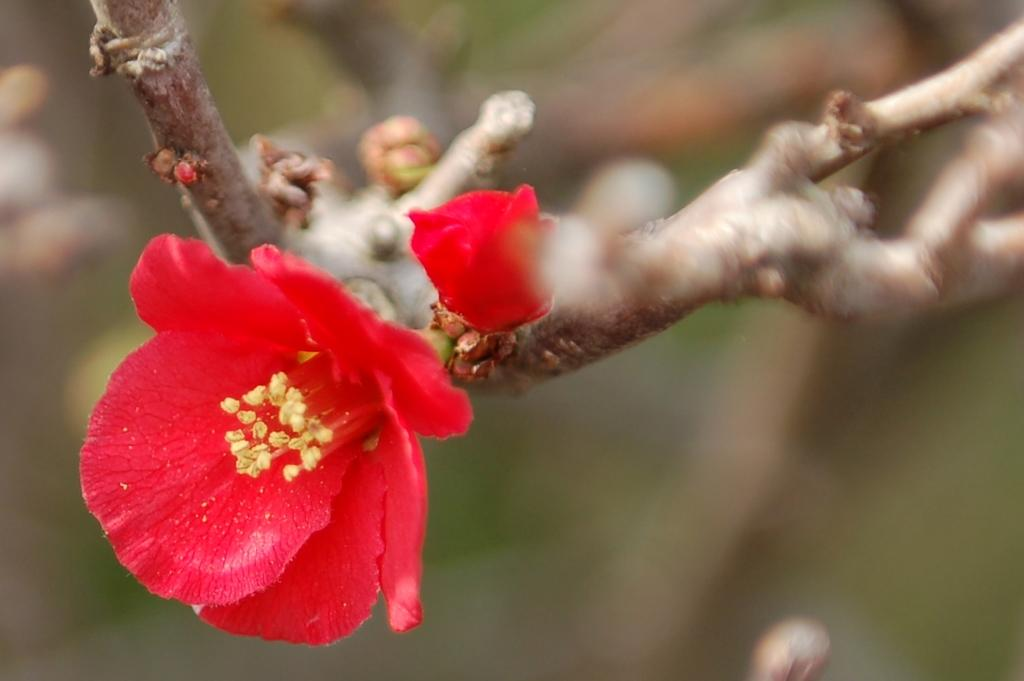How many flowers can be seen in the image? There are 2 flowers in the image. What color are the flowers? The flowers are red in color. Are the flowers attached to anything? Yes, the flowers are on stems. What can be observed about the background of the image? The background of the image is blurred. What type of nerve can be seen in the image? There is no nerve present in the image; it features two red flowers on stems. How many bears are visible in the image? There are no bears present in the image. 